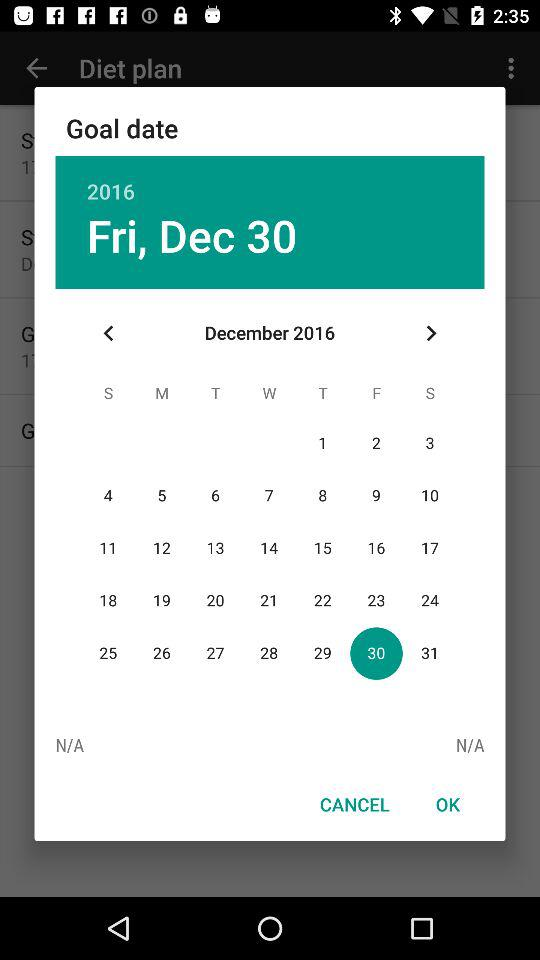What is the selected date? The selected date is Friday, December 30, 2016. 